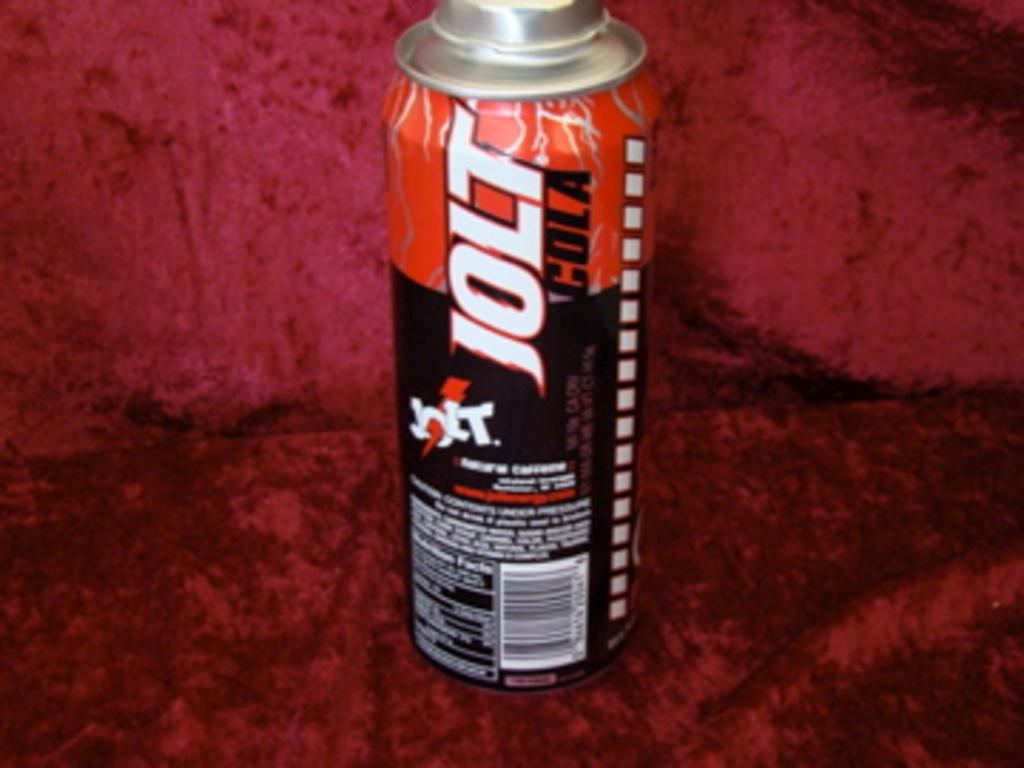Provide a one-sentence caption for the provided image. Jolt Cola is the name shown on the can of this energy drink. 